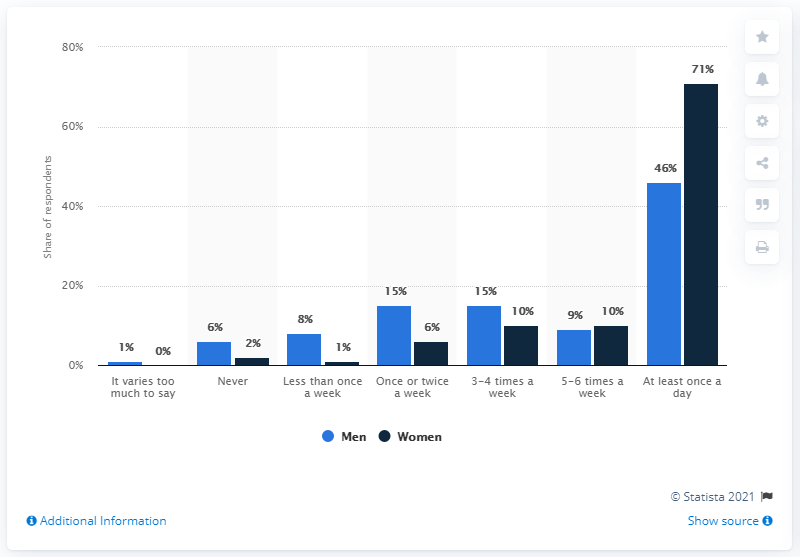Specify some key components in this picture. Women typically cook fewer than five to six times per week, while men tend to cook less frequently. According to the given text, it can be stated that 46% of men cook or prepare food at least once a day. 